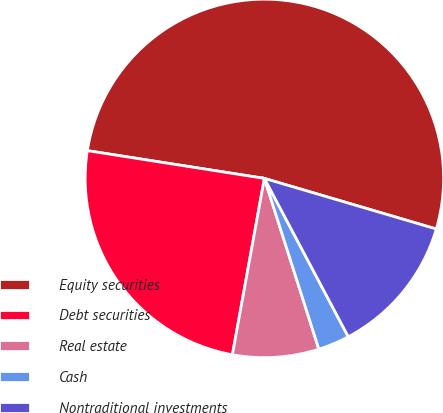<chart> <loc_0><loc_0><loc_500><loc_500><pie_chart><fcel>Equity securities<fcel>Debt securities<fcel>Real estate<fcel>Cash<fcel>Nontraditional investments<nl><fcel>52.08%<fcel>24.62%<fcel>7.77%<fcel>2.84%<fcel>12.69%<nl></chart> 